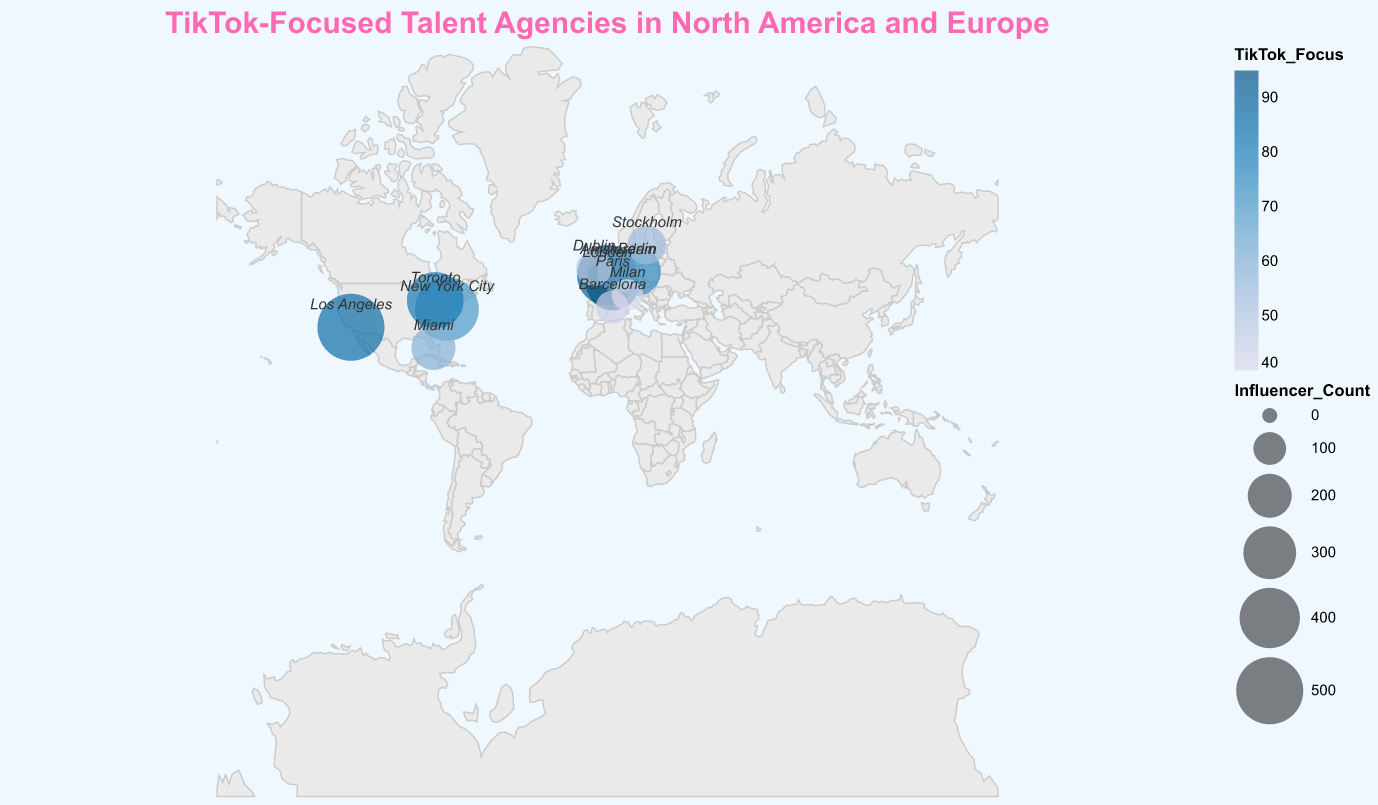What is the title of the plot? The title is an introductory text that summarizes the main subject of the plot, positioned at the top. It reads "TikTok-Focused Talent Agencies in North America and Europe".
Answer: "TikTok-Focused Talent Agencies in North America and Europe" Which city has the highest TikTok focus score? The highest TikTok focus score can be identified by looking for the city with the largest color value. Paris, France, with a score of 95, has the highest TikTok focus.
Answer: Paris Which two cities have the most social media influencers represented? The number of influencers is indicated by the size of the circles. Los Angeles, USA, and New York City, USA, have the two largest circles, representing 500 and 450 influencers, respectively.
Answer: Los Angeles and New York City Which agency has the lowest TikTok focus score, and what is that score? The smallest color value indicates the lowest TikTok focus score. Milan, Italy's agency XOMAD, has the lowest TikTok focus score of 40.
Answer: XOMAD, 40 How many cities in Europe have a TikTok focus score of 70 or above? The European cities with scores 70 or above are London (90), Paris (95), Berlin (75), and Amsterdam (65). So, three cities meet this criterion.
Answer: 3 Compare the TikTok focus score between Viral Nation in Los Angeles and Instabrand in Toronto. Los Angeles' Viral Nation has a TikTok focus score of 85, and Toronto's Instabrand has a score of 80. 85 is greater than 80.
Answer: Los Angeles > Toronto What is the average TikTok focus score for agencies located in the USA? The agencies in the USA (Viral Nation, Whalar, Obviously) have TikTok focus scores of 85, 70, and 60 respectively. (85 + 70 + 60) / 3 = 71.67.
Answer: 71.67 Compare the number of influencers between The Influencer Marketing Factory in London and Fanbytes in Paris. London has 400 influencers, and Paris has 300. 400 is greater than 300.
Answer: London > Paris Which city has both the smallest circle (least number of influencers) and the lowest TikTok focus score? Milan, Italy, with 90 influencers and a TikTok focus score of 40, has the smallest circle and the lowest TikTok focus score.
Answer: Milan 